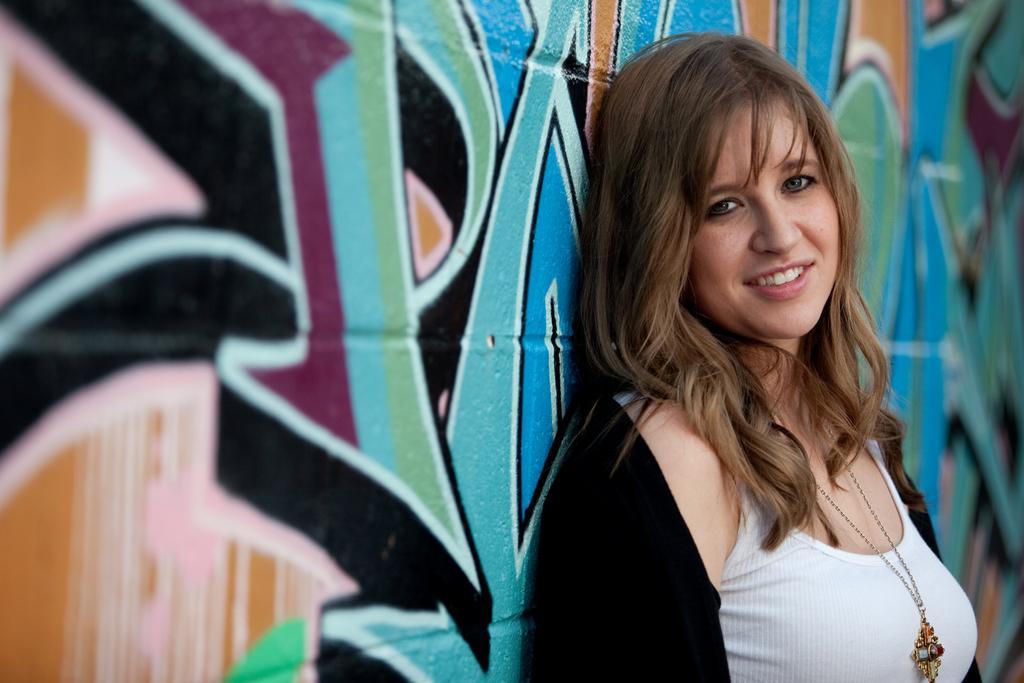Describe this image in one or two sentences. In this picture I can see there is a woman standing, she is wearing a white shirt, black coat and a necklace, she is smiling. There is a wall behind her and there is graffiti art on it. 